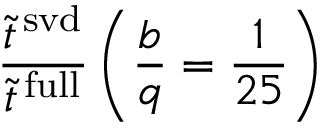Convert formula to latex. <formula><loc_0><loc_0><loc_500><loc_500>\frac { \tilde { t } ^ { \, s v d } } { \tilde { t } ^ { \, f u l l } } \left ( \frac { b } { q } = \frac { 1 } { 2 5 } \right )</formula> 